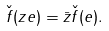<formula> <loc_0><loc_0><loc_500><loc_500>\check { f } ( z e ) = \bar { z } \check { f } ( e ) .</formula> 